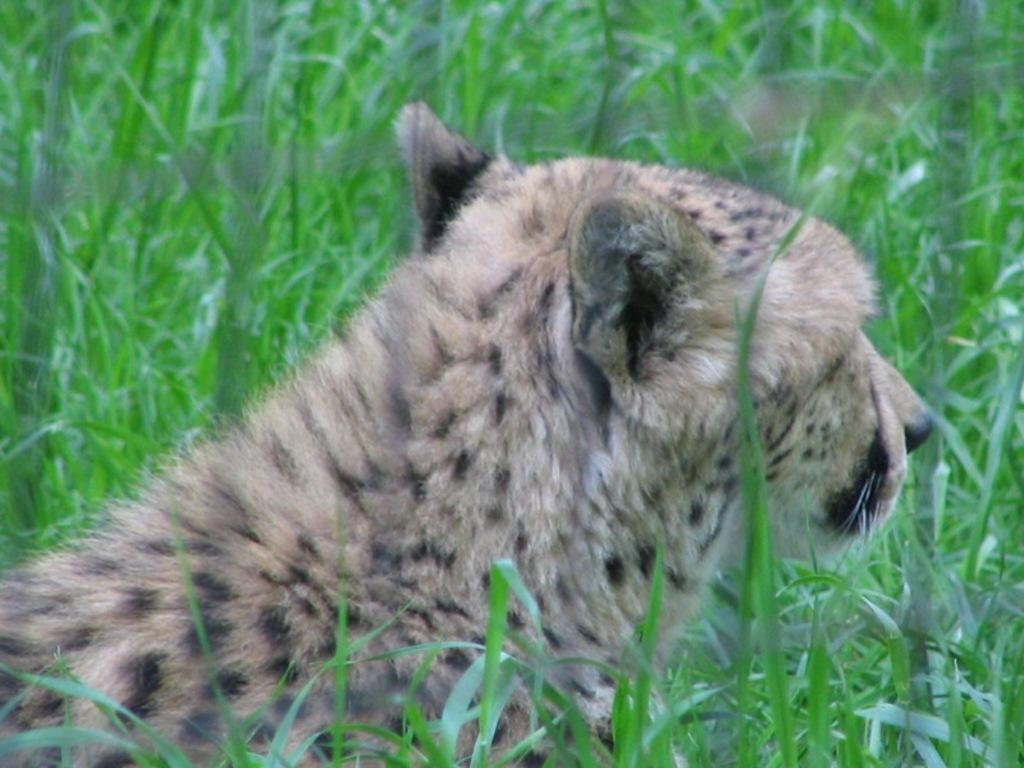What type of animal is present in the image? There is an animal in the image, but the specific type of animal is not mentioned in the provided facts. Can you describe the location of the animal in the image? The animal is in between the grass in the image. What type of machine is the animal using in the image? There is no machine present in the image. What type of motion is the animal exhibiting in the image? The provided facts do not mention any specific motion exhibited by the animal in the image. 